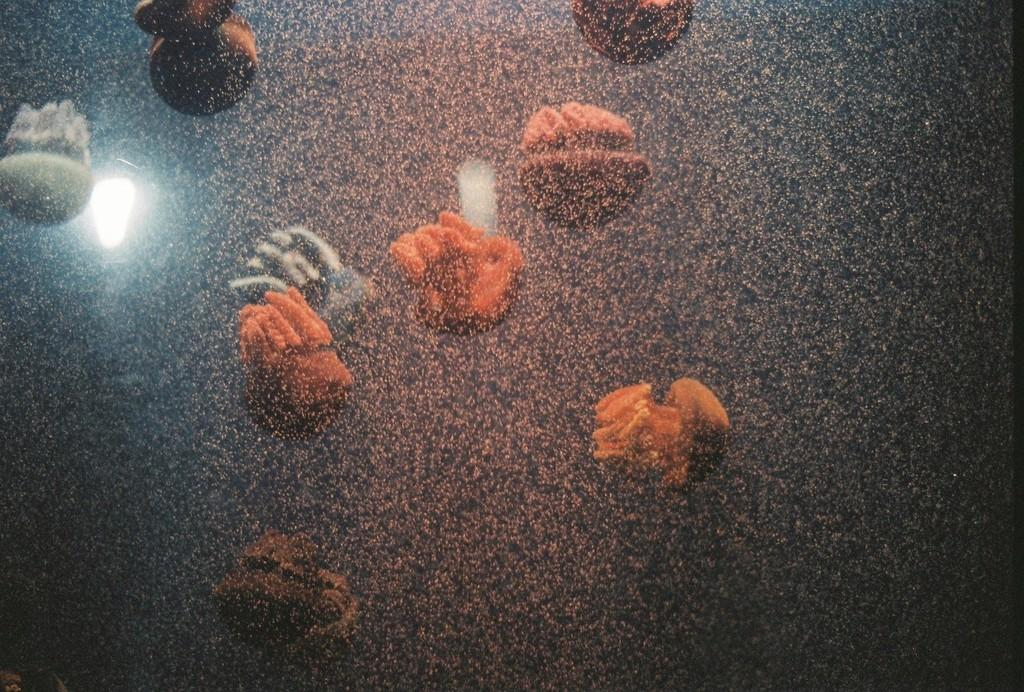What type of material is featured in the image? The image contains granite marble. What can be seen on the surface of the marble? There are reflections of objects and lights on the marble. What type of lock can be seen on the marble in the image? There is no lock present on the marble in the image. What type of voice can be heard coming from the marble in the image? The marble in the image is not capable of producing a voice, as it is an inanimate object. 